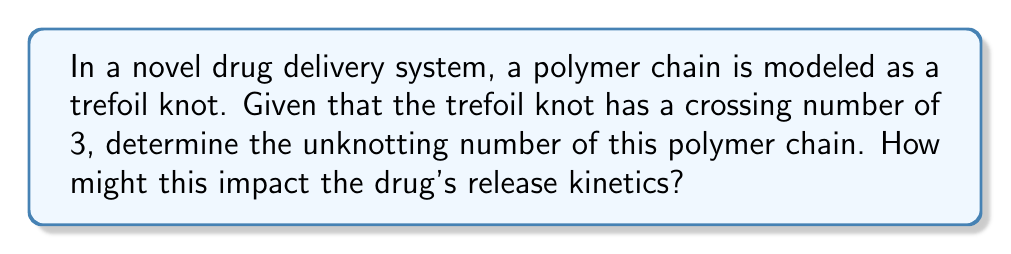Could you help me with this problem? To solve this problem, let's follow these steps:

1. Understand the concept of unknotting number:
   The unknotting number of a knot is the minimum number of times the knot must be passed through itself to untie it completely.

2. Recall properties of the trefoil knot:
   - The trefoil knot is the simplest non-trivial knot.
   - It has a crossing number of 3, meaning it has three crossings in its minimal diagram.

3. Determine the unknotting number:
   - For the trefoil knot, the unknotting number is equal to 1.
   - This means that a single crossing change is sufficient and necessary to transform the trefoil knot into the unknot (trivial knot).

4. Mathematically, we can express this as:
   $$u(T) = 1$$
   where $u(T)$ represents the unknotting number of the trefoil knot.

5. Impact on drug release kinetics:
   - The unknotting number provides insight into the complexity of the polymer chain's configuration.
   - A higher unknotting number would indicate a more complex knot, potentially leading to slower drug release as the polymer takes longer to unravel.
   - With an unknotting number of 1, the trefoil knot suggests a relatively simple configuration that may allow for controlled, but not overly delayed, drug release.
   - The pharmacologist could use this information to predict and model the drug's release profile, considering how the polymer's unknotting process might affect the availability of the drug over time.
Answer: 1 